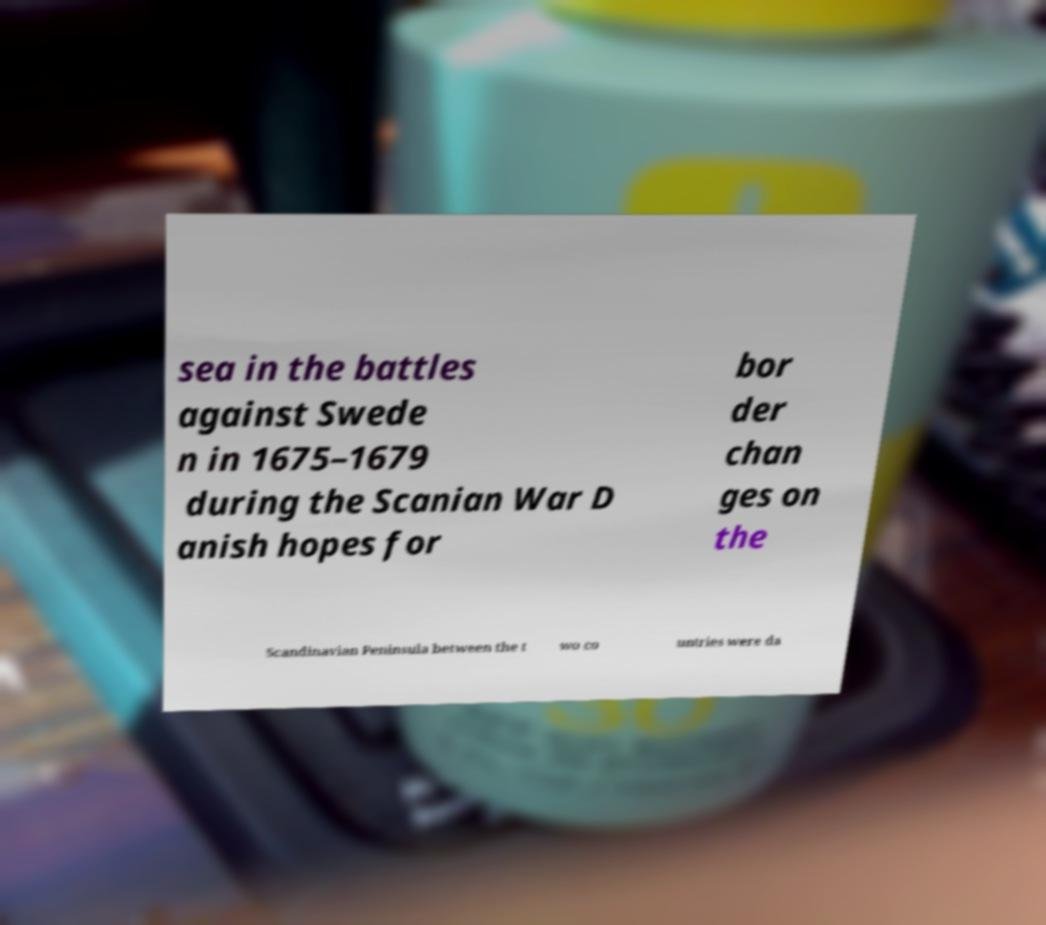Please identify and transcribe the text found in this image. sea in the battles against Swede n in 1675–1679 during the Scanian War D anish hopes for bor der chan ges on the Scandinavian Peninsula between the t wo co untries were da 